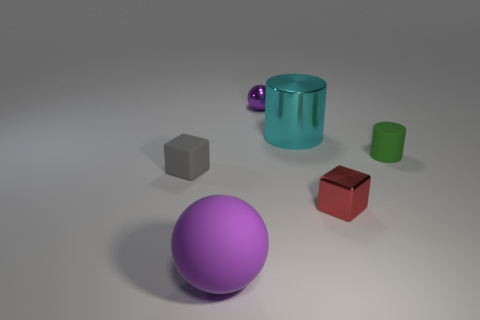What number of cyan shiny things have the same shape as the green thing?
Give a very brief answer. 1. How many matte things are the same color as the tiny sphere?
Offer a terse response. 1. Do the metallic object to the right of the large cyan object and the tiny metal thing behind the gray cube have the same shape?
Offer a terse response. No. There is a purple ball that is on the right side of the rubber thing that is in front of the red shiny thing; how many cyan metallic cylinders are to the right of it?
Offer a terse response. 1. What is the purple thing that is behind the rubber thing that is right of the matte thing that is in front of the small gray thing made of?
Ensure brevity in your answer.  Metal. Is the material of the large thing that is behind the rubber block the same as the green thing?
Provide a succinct answer. No. What number of spheres are the same size as the matte cylinder?
Give a very brief answer. 1. Is the number of large purple rubber spheres in front of the green thing greater than the number of cyan shiny objects that are in front of the large ball?
Your answer should be compact. Yes. Is there a small red thing of the same shape as the large matte object?
Provide a succinct answer. No. There is a purple sphere that is left of the ball behind the small red metallic block; what size is it?
Your answer should be very brief. Large. 